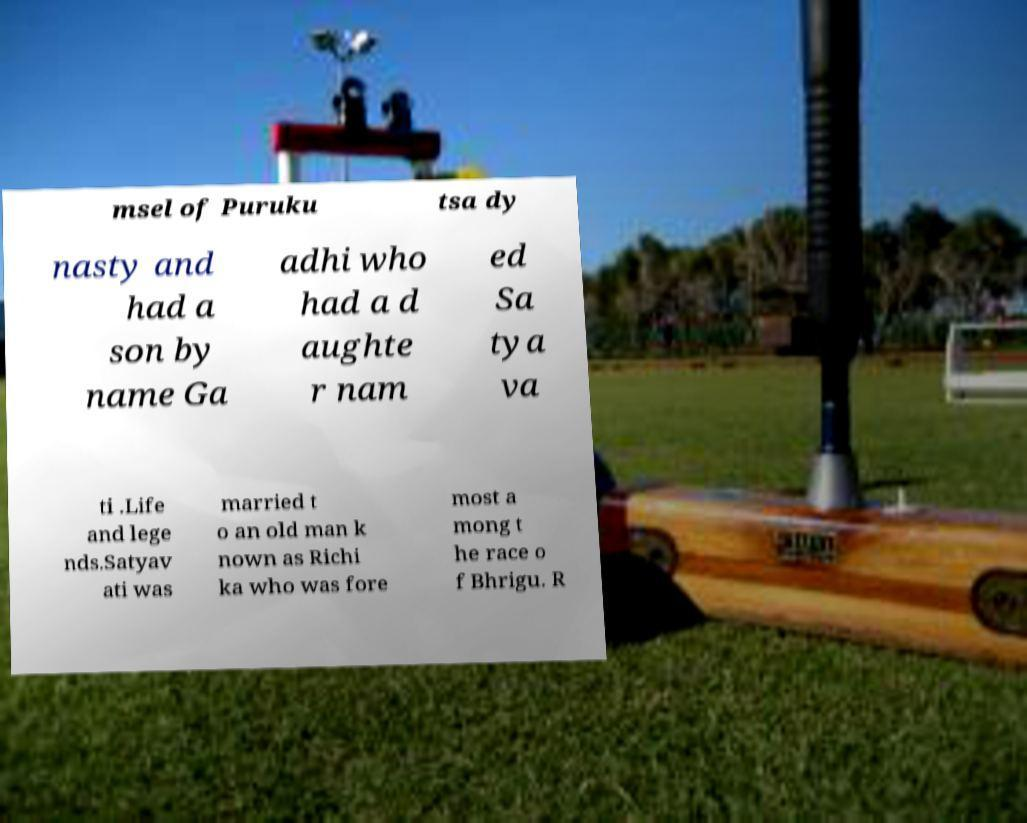For documentation purposes, I need the text within this image transcribed. Could you provide that? msel of Puruku tsa dy nasty and had a son by name Ga adhi who had a d aughte r nam ed Sa tya va ti .Life and lege nds.Satyav ati was married t o an old man k nown as Richi ka who was fore most a mong t he race o f Bhrigu. R 